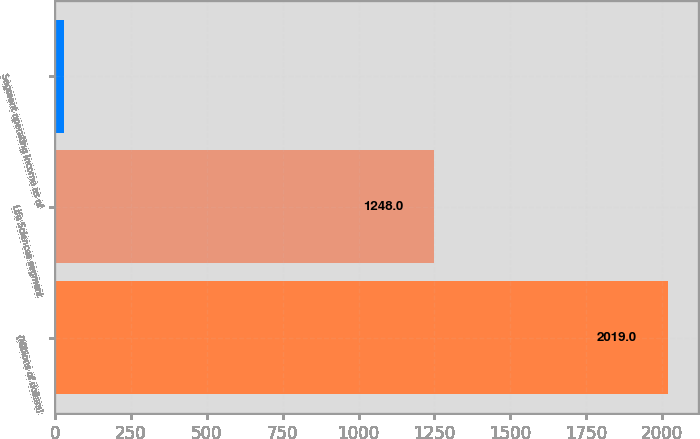Convert chart. <chart><loc_0><loc_0><loc_500><loc_500><bar_chart><fcel>(Millions of dollars)<fcel>Life Sciences segment<fcel>Segment operating income as of<nl><fcel>2019<fcel>1248<fcel>29<nl></chart> 